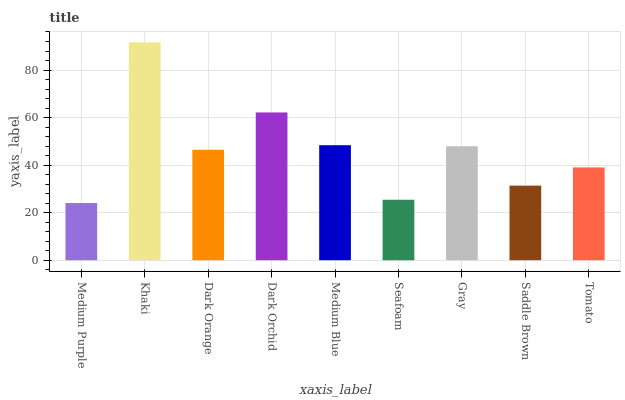Is Medium Purple the minimum?
Answer yes or no. Yes. Is Khaki the maximum?
Answer yes or no. Yes. Is Dark Orange the minimum?
Answer yes or no. No. Is Dark Orange the maximum?
Answer yes or no. No. Is Khaki greater than Dark Orange?
Answer yes or no. Yes. Is Dark Orange less than Khaki?
Answer yes or no. Yes. Is Dark Orange greater than Khaki?
Answer yes or no. No. Is Khaki less than Dark Orange?
Answer yes or no. No. Is Dark Orange the high median?
Answer yes or no. Yes. Is Dark Orange the low median?
Answer yes or no. Yes. Is Seafoam the high median?
Answer yes or no. No. Is Medium Blue the low median?
Answer yes or no. No. 